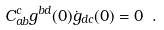<formula> <loc_0><loc_0><loc_500><loc_500>C ^ { c } _ { a b } g ^ { b d } ( 0 ) \dot { g } _ { d c } ( 0 ) = 0 \ .</formula> 